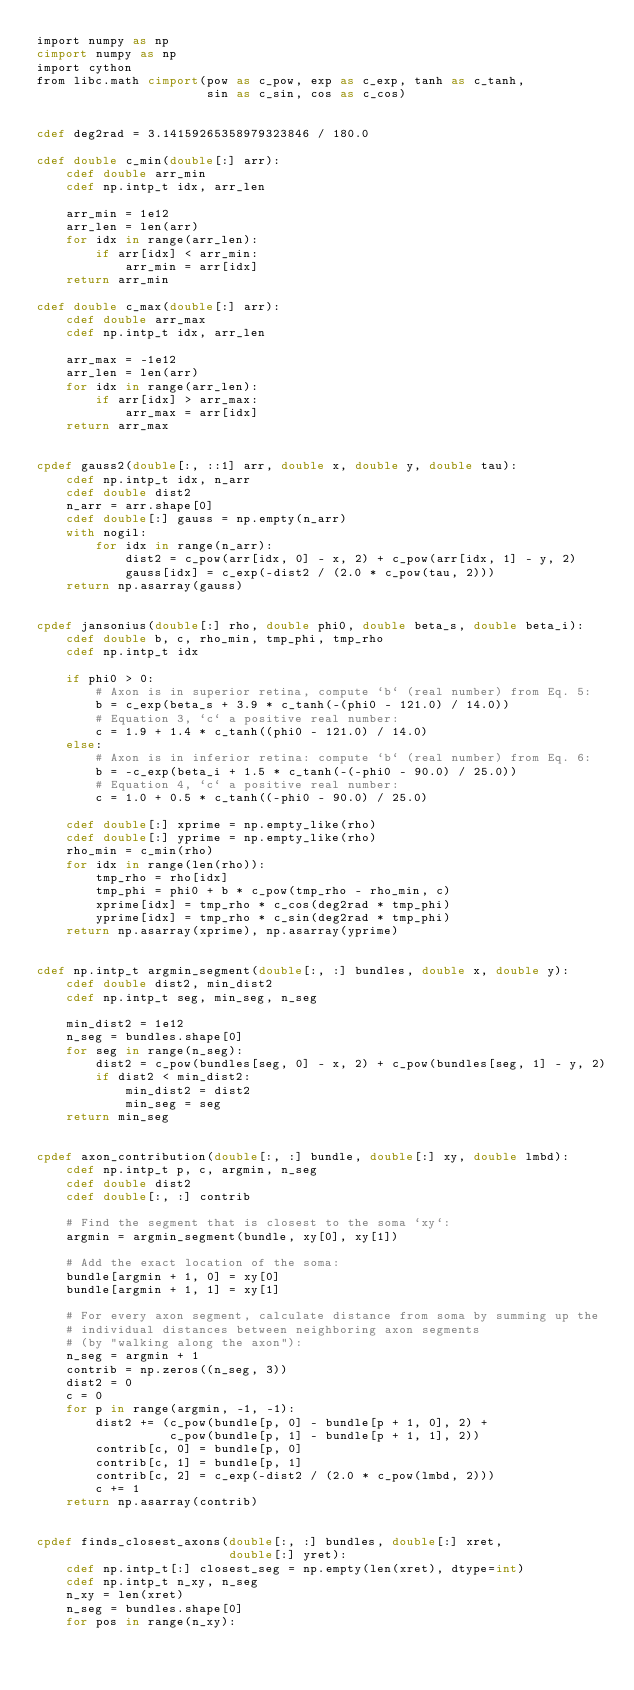Convert code to text. <code><loc_0><loc_0><loc_500><loc_500><_Cython_>import numpy as np
cimport numpy as np
import cython
from libc.math cimport(pow as c_pow, exp as c_exp, tanh as c_tanh,
                       sin as c_sin, cos as c_cos)


cdef deg2rad = 3.14159265358979323846 / 180.0

cdef double c_min(double[:] arr):
    cdef double arr_min
    cdef np.intp_t idx, arr_len

    arr_min = 1e12
    arr_len = len(arr)
    for idx in range(arr_len):
        if arr[idx] < arr_min:
            arr_min = arr[idx]
    return arr_min

cdef double c_max(double[:] arr):
    cdef double arr_max
    cdef np.intp_t idx, arr_len

    arr_max = -1e12
    arr_len = len(arr)
    for idx in range(arr_len):
        if arr[idx] > arr_max:
            arr_max = arr[idx]
    return arr_max


cpdef gauss2(double[:, ::1] arr, double x, double y, double tau):
    cdef np.intp_t idx, n_arr
    cdef double dist2
    n_arr = arr.shape[0]
    cdef double[:] gauss = np.empty(n_arr)
    with nogil:
        for idx in range(n_arr):
            dist2 = c_pow(arr[idx, 0] - x, 2) + c_pow(arr[idx, 1] - y, 2)
            gauss[idx] = c_exp(-dist2 / (2.0 * c_pow(tau, 2)))
    return np.asarray(gauss)


cpdef jansonius(double[:] rho, double phi0, double beta_s, double beta_i):
    cdef double b, c, rho_min, tmp_phi, tmp_rho
    cdef np.intp_t idx

    if phi0 > 0:
        # Axon is in superior retina, compute `b` (real number) from Eq. 5:
        b = c_exp(beta_s + 3.9 * c_tanh(-(phi0 - 121.0) / 14.0))
        # Equation 3, `c` a positive real number:
        c = 1.9 + 1.4 * c_tanh((phi0 - 121.0) / 14.0)
    else:
        # Axon is in inferior retina: compute `b` (real number) from Eq. 6:
        b = -c_exp(beta_i + 1.5 * c_tanh(-(-phi0 - 90.0) / 25.0))
        # Equation 4, `c` a positive real number:
        c = 1.0 + 0.5 * c_tanh((-phi0 - 90.0) / 25.0)

    cdef double[:] xprime = np.empty_like(rho)
    cdef double[:] yprime = np.empty_like(rho)
    rho_min = c_min(rho)
    for idx in range(len(rho)):
        tmp_rho = rho[idx]
        tmp_phi = phi0 + b * c_pow(tmp_rho - rho_min, c)
        xprime[idx] = tmp_rho * c_cos(deg2rad * tmp_phi)
        yprime[idx] = tmp_rho * c_sin(deg2rad * tmp_phi)
    return np.asarray(xprime), np.asarray(yprime)


cdef np.intp_t argmin_segment(double[:, :] bundles, double x, double y):
    cdef double dist2, min_dist2
    cdef np.intp_t seg, min_seg, n_seg

    min_dist2 = 1e12
    n_seg = bundles.shape[0]
    for seg in range(n_seg):
        dist2 = c_pow(bundles[seg, 0] - x, 2) + c_pow(bundles[seg, 1] - y, 2)
        if dist2 < min_dist2:
            min_dist2 = dist2
            min_seg = seg
    return min_seg


cpdef axon_contribution(double[:, :] bundle, double[:] xy, double lmbd):
    cdef np.intp_t p, c, argmin, n_seg
    cdef double dist2
    cdef double[:, :] contrib

    # Find the segment that is closest to the soma `xy`:
    argmin = argmin_segment(bundle, xy[0], xy[1])

    # Add the exact location of the soma:
    bundle[argmin + 1, 0] = xy[0]
    bundle[argmin + 1, 1] = xy[1]

    # For every axon segment, calculate distance from soma by summing up the
    # individual distances between neighboring axon segments
    # (by "walking along the axon"):
    n_seg = argmin + 1
    contrib = np.zeros((n_seg, 3))
    dist2 = 0
    c = 0
    for p in range(argmin, -1, -1):
        dist2 += (c_pow(bundle[p, 0] - bundle[p + 1, 0], 2) +
                  c_pow(bundle[p, 1] - bundle[p + 1, 1], 2))
        contrib[c, 0] = bundle[p, 0]
        contrib[c, 1] = bundle[p, 1]
        contrib[c, 2] = c_exp(-dist2 / (2.0 * c_pow(lmbd, 2)))
        c += 1
    return np.asarray(contrib)


cpdef finds_closest_axons(double[:, :] bundles, double[:] xret,
                          double[:] yret):
    cdef np.intp_t[:] closest_seg = np.empty(len(xret), dtype=int)
    cdef np.intp_t n_xy, n_seg
    n_xy = len(xret)
    n_seg = bundles.shape[0]
    for pos in range(n_xy):</code> 